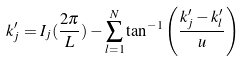Convert formula to latex. <formula><loc_0><loc_0><loc_500><loc_500>k ^ { \prime } _ { j } = I _ { j } ( \frac { 2 \pi } { L } ) - \sum ^ { N } _ { l = 1 } \tan ^ { - 1 } \left ( \frac { k ^ { \prime } _ { j } - k ^ { \prime } _ { l } } { u } \right )</formula> 